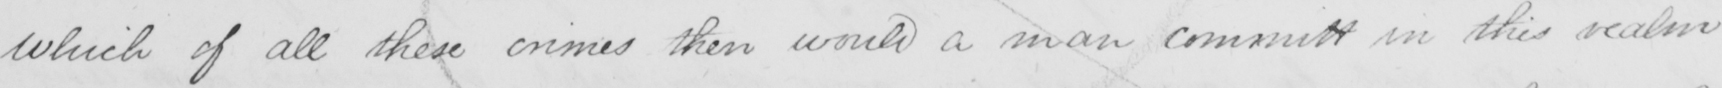Please transcribe the handwritten text in this image. which of all these crimes then would a man committ in this realm 